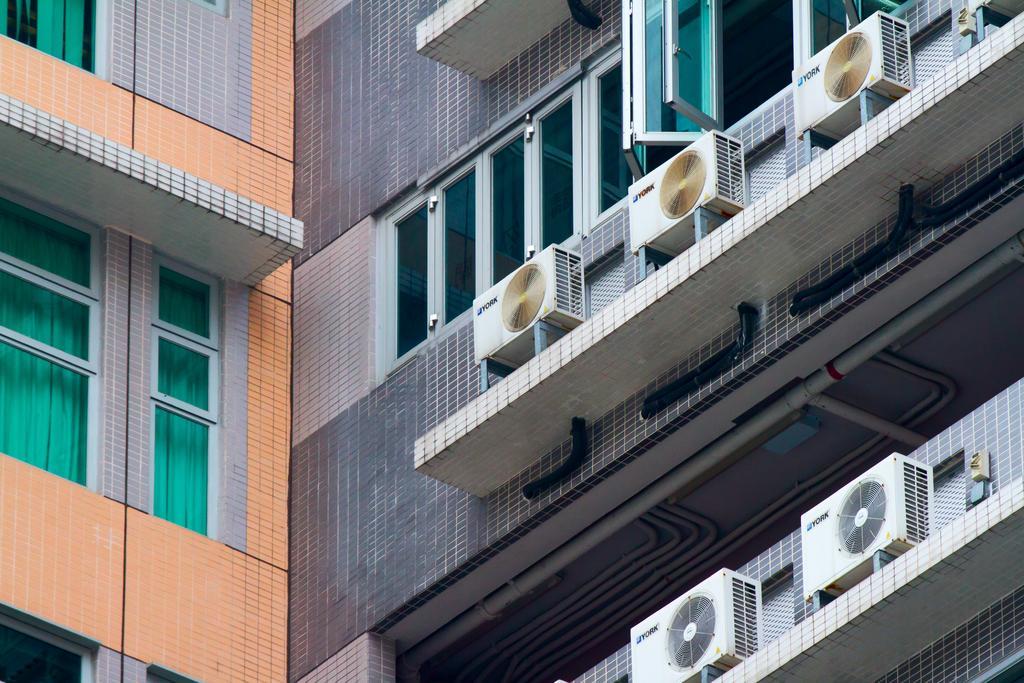How would you summarize this image in a sentence or two? In this image we can see a building. On the building we can see the windows with glass, air conditioners and pipes. On the left side, we can see curtains through the glass of the windows. 